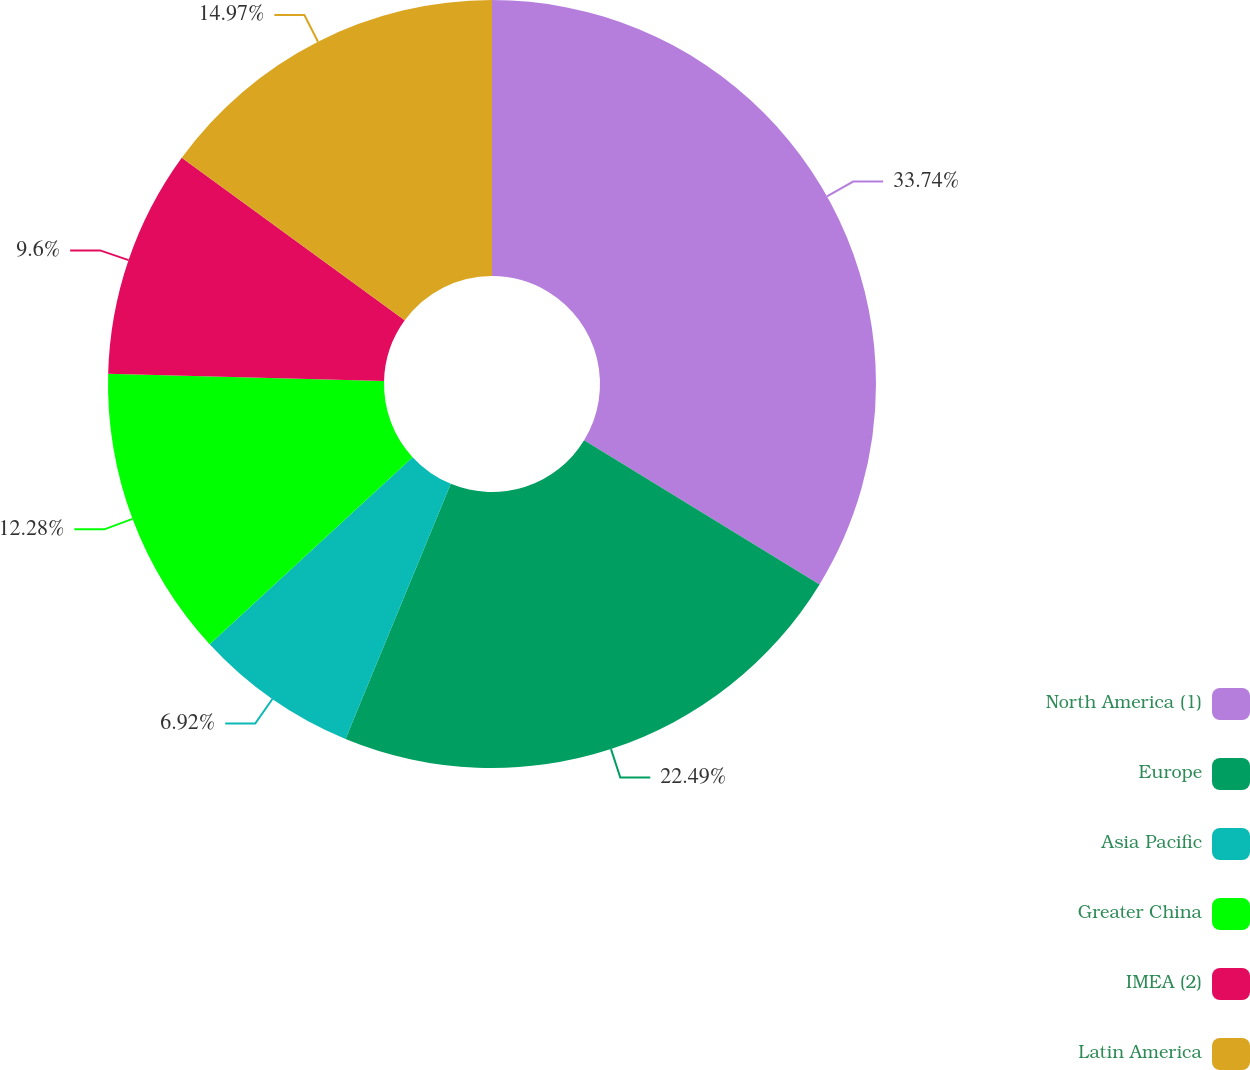Convert chart to OTSL. <chart><loc_0><loc_0><loc_500><loc_500><pie_chart><fcel>North America (1)<fcel>Europe<fcel>Asia Pacific<fcel>Greater China<fcel>IMEA (2)<fcel>Latin America<nl><fcel>33.74%<fcel>22.49%<fcel>6.92%<fcel>12.28%<fcel>9.6%<fcel>14.97%<nl></chart> 